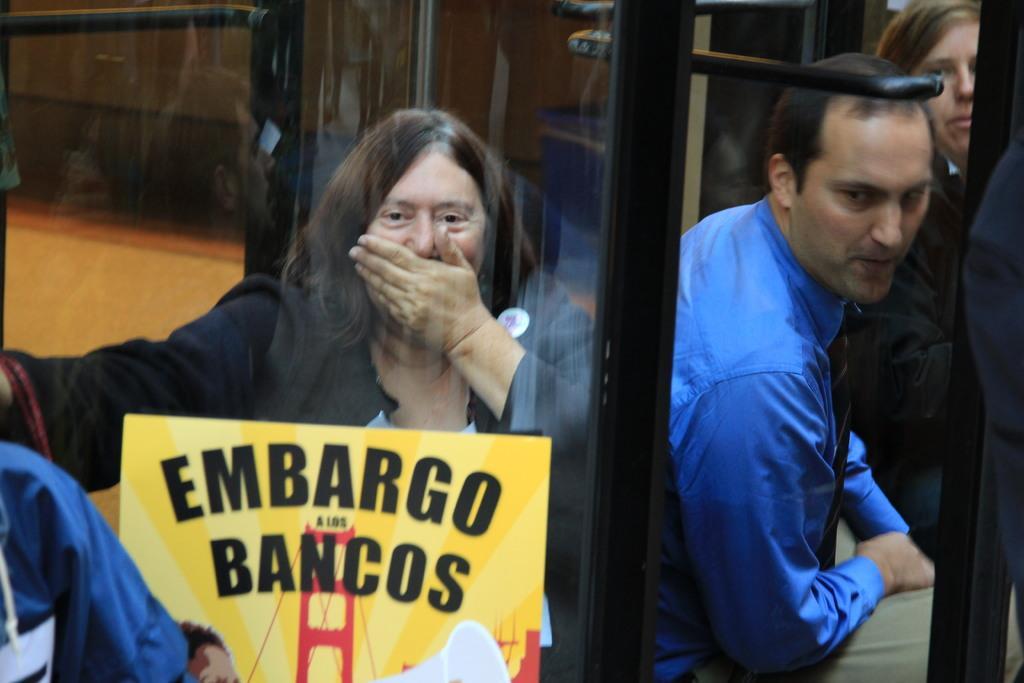Describe this image in one or two sentences. In this image in the center there are persons sitting and in the front there is a board with some text written on it. In the background there is a vehicle and there is glass in the center. 